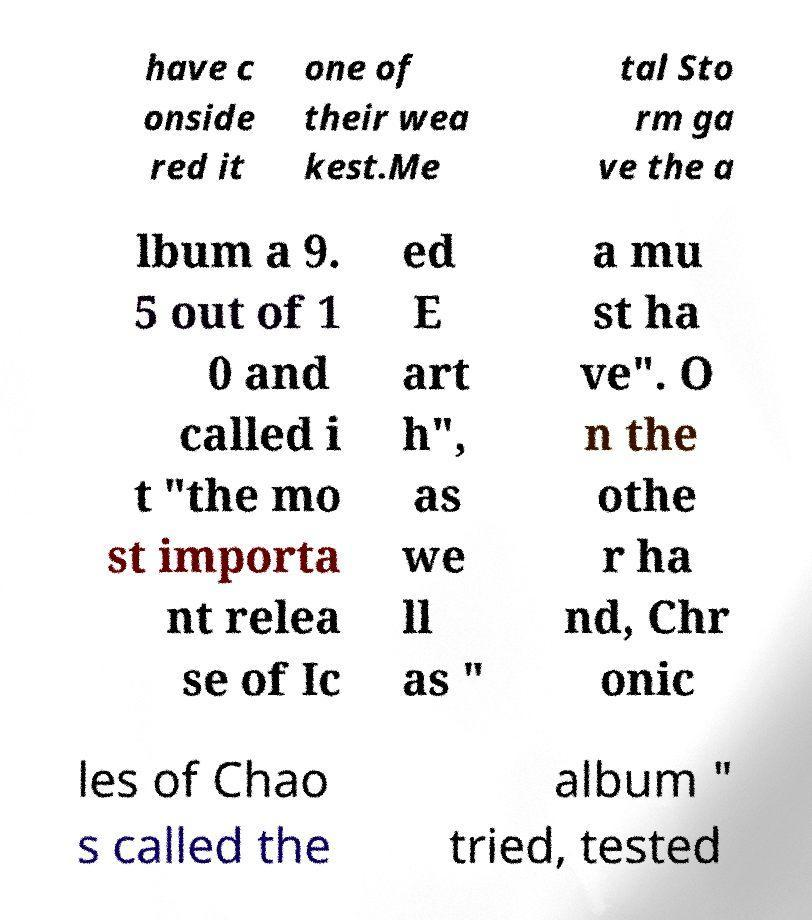Could you assist in decoding the text presented in this image and type it out clearly? have c onside red it one of their wea kest.Me tal Sto rm ga ve the a lbum a 9. 5 out of 1 0 and called i t "the mo st importa nt relea se of Ic ed E art h", as we ll as " a mu st ha ve". O n the othe r ha nd, Chr onic les of Chao s called the album " tried, tested 